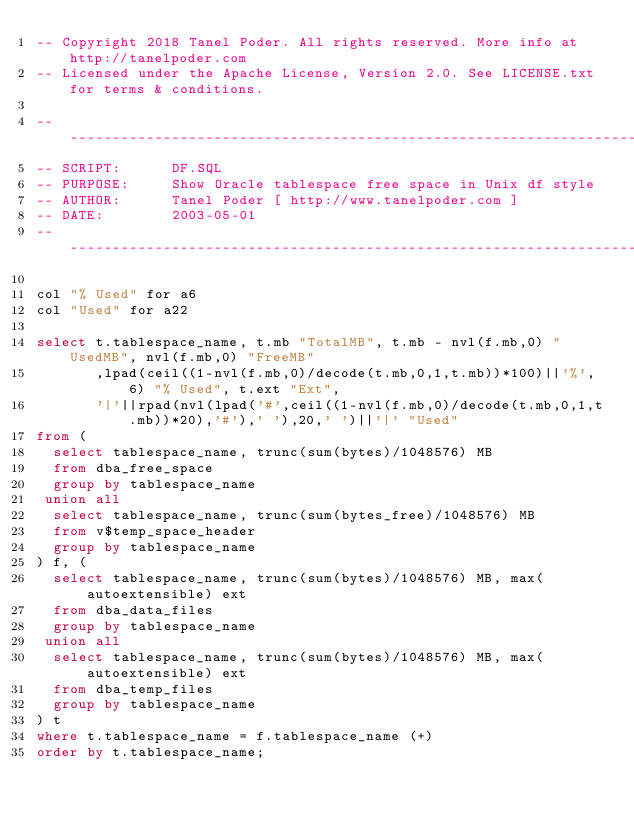Convert code to text. <code><loc_0><loc_0><loc_500><loc_500><_SQL_>-- Copyright 2018 Tanel Poder. All rights reserved. More info at http://tanelpoder.com
-- Licensed under the Apache License, Version 2.0. See LICENSE.txt for terms & conditions.

-------------------------------------------------------------------------------------------
-- SCRIPT:      DF.SQL
-- PURPOSE:     Show Oracle tablespace free space in Unix df style
-- AUTHOR:      Tanel Poder [ http://www.tanelpoder.com ]
-- DATE:        2003-05-01
-------------------------------------------------------------------------------------------

col "% Used" for a6
col "Used" for a22

select t.tablespace_name, t.mb "TotalMB", t.mb - nvl(f.mb,0) "UsedMB", nvl(f.mb,0) "FreeMB"
       ,lpad(ceil((1-nvl(f.mb,0)/decode(t.mb,0,1,t.mb))*100)||'%', 6) "% Used", t.ext "Ext", 
       '|'||rpad(nvl(lpad('#',ceil((1-nvl(f.mb,0)/decode(t.mb,0,1,t.mb))*20),'#'),' '),20,' ')||'|' "Used"
from (
  select tablespace_name, trunc(sum(bytes)/1048576) MB
  from dba_free_space
  group by tablespace_name
 union all
  select tablespace_name, trunc(sum(bytes_free)/1048576) MB
  from v$temp_space_header
  group by tablespace_name
) f, (
  select tablespace_name, trunc(sum(bytes)/1048576) MB, max(autoextensible) ext
  from dba_data_files
  group by tablespace_name
 union all
  select tablespace_name, trunc(sum(bytes)/1048576) MB, max(autoextensible) ext
  from dba_temp_files
  group by tablespace_name
) t
where t.tablespace_name = f.tablespace_name (+)
order by t.tablespace_name;

</code> 